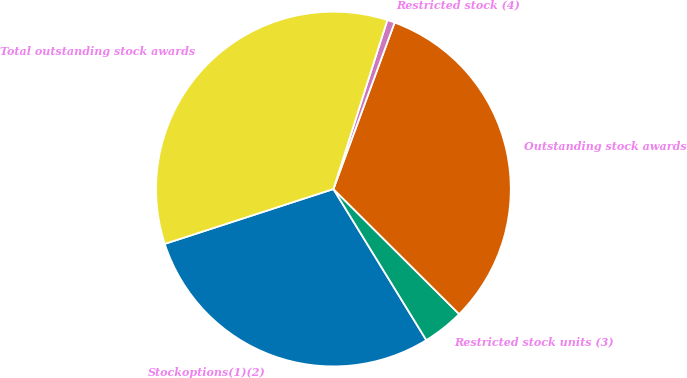<chart> <loc_0><loc_0><loc_500><loc_500><pie_chart><fcel>Stockoptions(1)(2)<fcel>Restricted stock units (3)<fcel>Outstanding stock awards<fcel>Restricted stock (4)<fcel>Total outstanding stock awards<nl><fcel>28.77%<fcel>3.77%<fcel>31.85%<fcel>0.69%<fcel>34.92%<nl></chart> 